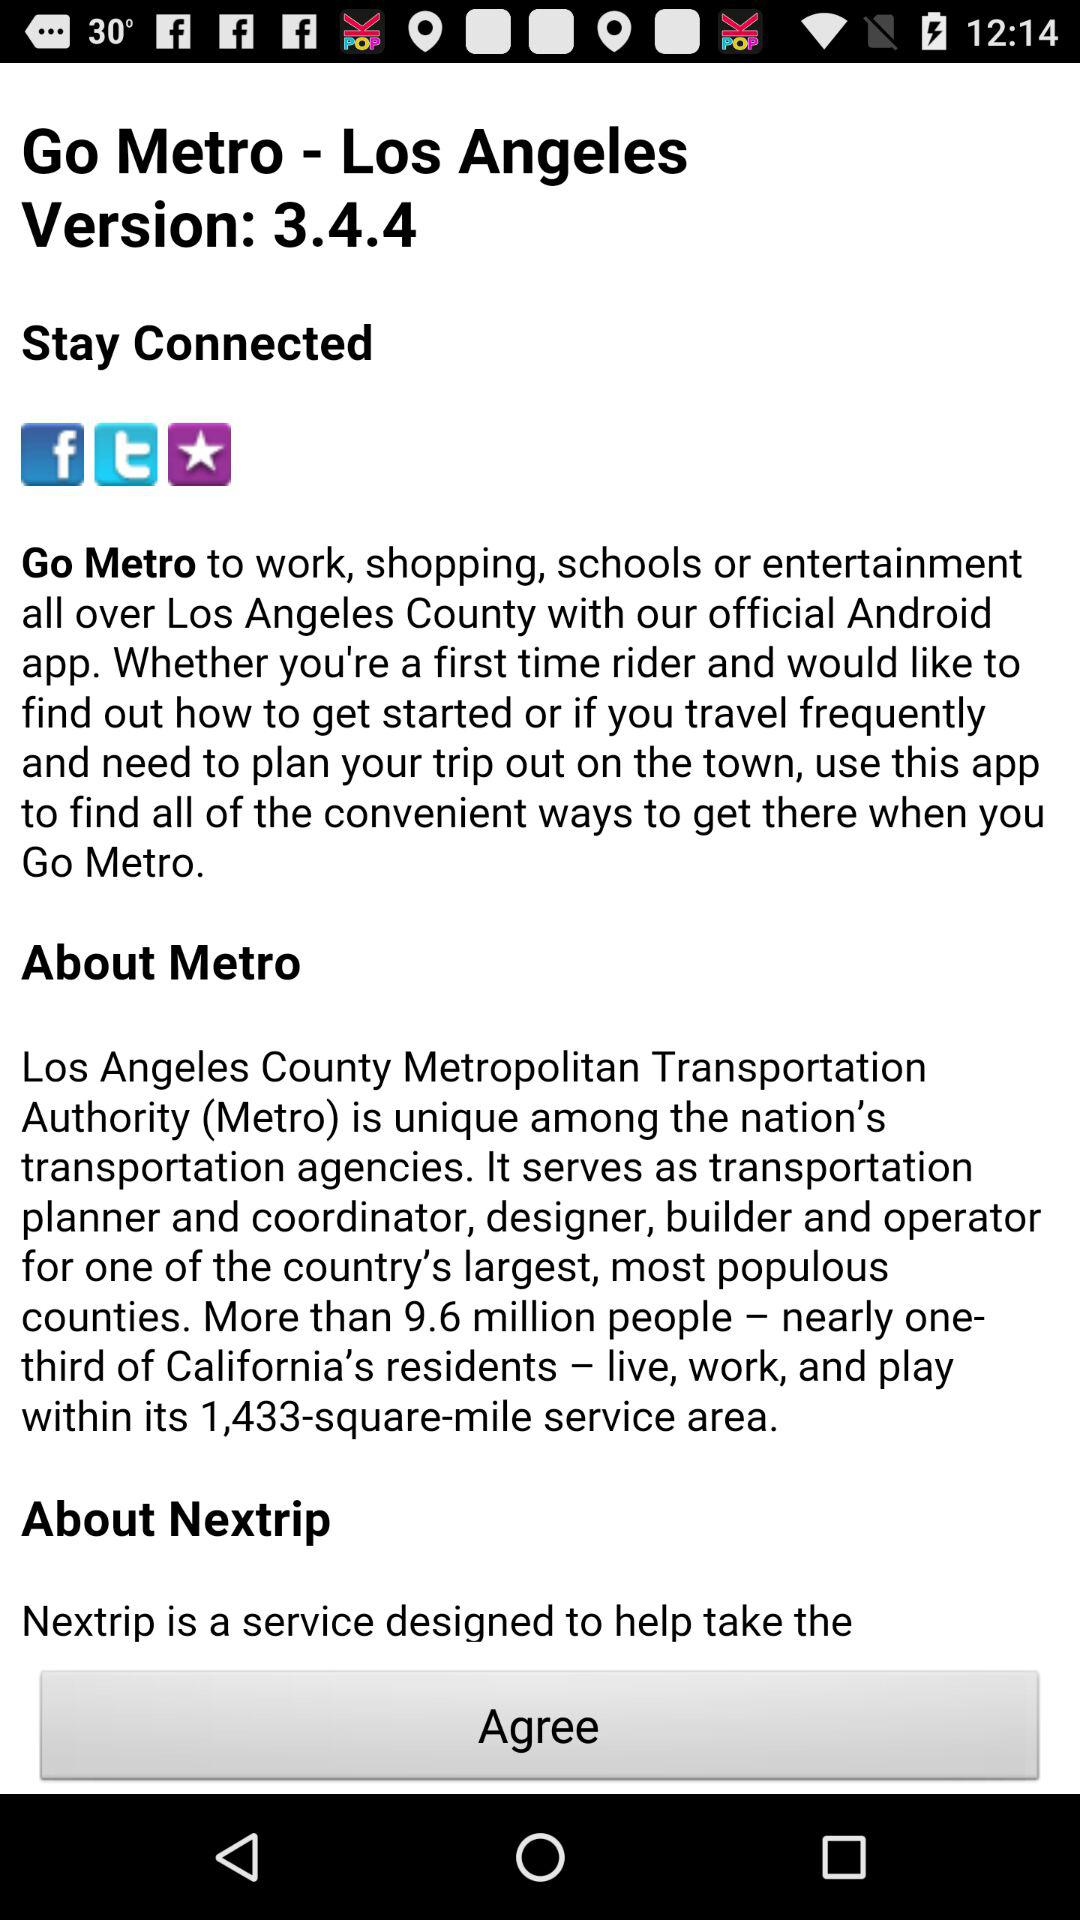What are the options to stay connected? The options to stay connected are "Facebook", "Twitter" and "iTunes Store". 